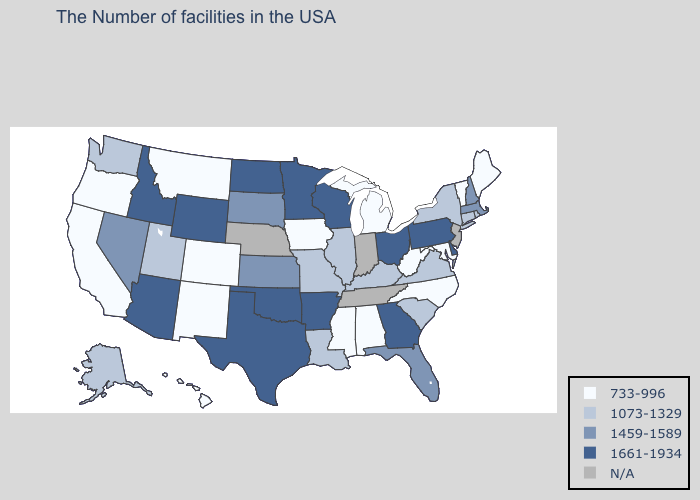What is the value of North Dakota?
Short answer required. 1661-1934. What is the lowest value in the South?
Concise answer only. 733-996. Is the legend a continuous bar?
Short answer required. No. Does the first symbol in the legend represent the smallest category?
Keep it brief. Yes. Name the states that have a value in the range N/A?
Answer briefly. New Jersey, Indiana, Tennessee, Nebraska. Does Connecticut have the highest value in the Northeast?
Short answer required. No. How many symbols are there in the legend?
Keep it brief. 5. Name the states that have a value in the range 1459-1589?
Concise answer only. Massachusetts, New Hampshire, Florida, Kansas, South Dakota, Nevada. Does Iowa have the lowest value in the MidWest?
Write a very short answer. Yes. Among the states that border South Dakota , which have the highest value?
Answer briefly. Minnesota, North Dakota, Wyoming. Name the states that have a value in the range 1459-1589?
Concise answer only. Massachusetts, New Hampshire, Florida, Kansas, South Dakota, Nevada. Does the map have missing data?
Short answer required. Yes. What is the value of South Dakota?
Be succinct. 1459-1589. Name the states that have a value in the range N/A?
Short answer required. New Jersey, Indiana, Tennessee, Nebraska. Name the states that have a value in the range 733-996?
Write a very short answer. Maine, Vermont, Maryland, North Carolina, West Virginia, Michigan, Alabama, Mississippi, Iowa, Colorado, New Mexico, Montana, California, Oregon, Hawaii. 